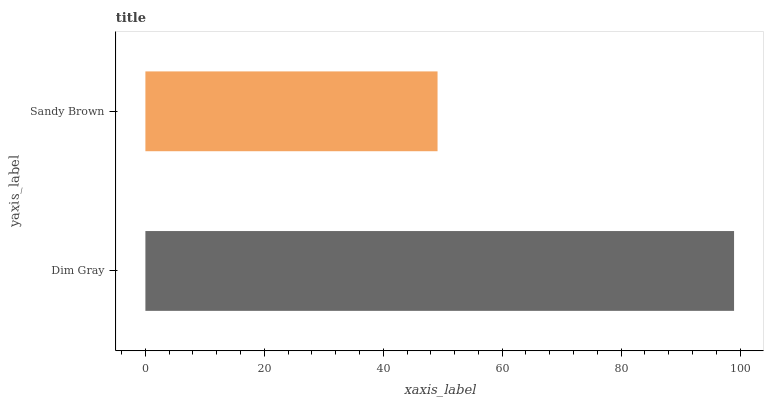Is Sandy Brown the minimum?
Answer yes or no. Yes. Is Dim Gray the maximum?
Answer yes or no. Yes. Is Sandy Brown the maximum?
Answer yes or no. No. Is Dim Gray greater than Sandy Brown?
Answer yes or no. Yes. Is Sandy Brown less than Dim Gray?
Answer yes or no. Yes. Is Sandy Brown greater than Dim Gray?
Answer yes or no. No. Is Dim Gray less than Sandy Brown?
Answer yes or no. No. Is Dim Gray the high median?
Answer yes or no. Yes. Is Sandy Brown the low median?
Answer yes or no. Yes. Is Sandy Brown the high median?
Answer yes or no. No. Is Dim Gray the low median?
Answer yes or no. No. 